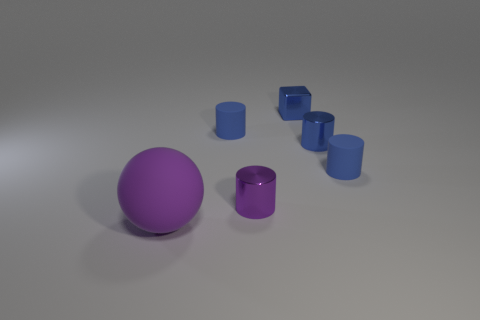How many blue cylinders must be subtracted to get 2 blue cylinders? 1 Subtract all blue cylinders. How many cylinders are left? 1 Subtract all purple cylinders. How many cylinders are left? 3 Add 1 small blue matte objects. How many objects exist? 7 Subtract all cylinders. How many objects are left? 2 Subtract 1 cubes. How many cubes are left? 0 Subtract all blue cylinders. Subtract all red balls. How many cylinders are left? 1 Subtract all blue blocks. How many red cylinders are left? 0 Subtract all small blue metal objects. Subtract all small rubber spheres. How many objects are left? 4 Add 2 blue metal cylinders. How many blue metal cylinders are left? 3 